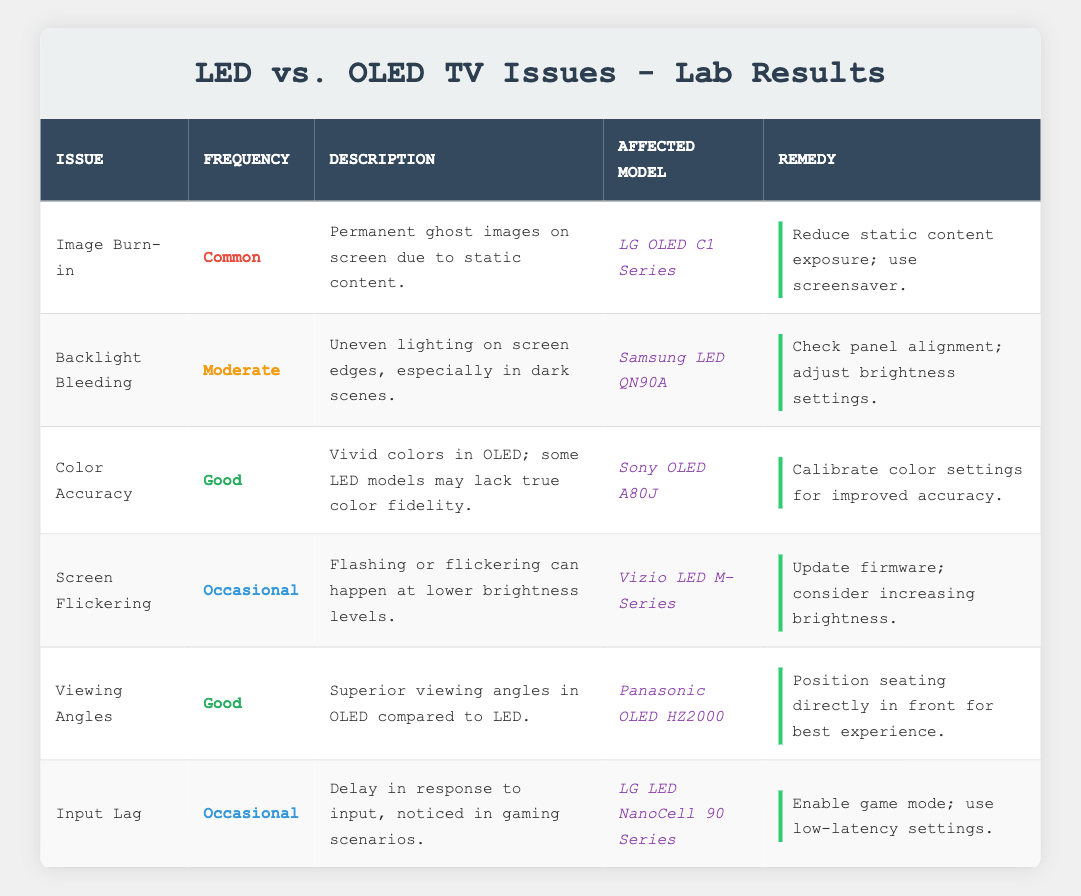What is the most common issue found with OLED televisions? By looking at the "Frequently" column in the table, I can see that "Image Burn-in" is labeled as "Common" for the affected model LG OLED C1 Series.
Answer: Image Burn-in Which model has a moderate issue with backlight bleeding? The table lists "Backlight Bleeding" under the affected model "Samsung LED QN90A" with a frequency of "Moderate."
Answer: Samsung LED QN90A What remedy is suggested for screen flickering in the Vizio LED M-Series? The remedy for screen flickering in the Vizio LED M-Series is to "Update firmware; consider increasing brightness," as shown in the table.
Answer: Update firmware; consider increasing brightness Is color accuracy noted as a problem for OLED models? The table notes that OLED models like the Sony OLED A80J have "Good" color accuracy, indicating that this is not a major problem for such models.
Answer: No Which issue has the frequency categorized as "Occasional"? By checking the frequency column, I identify "Screen Flickering" and "Input Lag" listed as occurring occasionally.
Answer: Screen Flickering, Input Lag Which type of television (LED or OLED) is mentioned to have superior viewing angles? The table states that OLED televisions, specifically the Panasonic OLED HZ2000, have "Superior viewing angles" compared to LED models.
Answer: OLED What is the remedy for the input lag experienced in gaming with the LG LED NanoCell 90 Series? The remedy according to the table is to "Enable game mode; use low-latency settings," which addresses the input lag.
Answer: Enable game mode; use low-latency settings How many issues are noted as being classified with a frequency of "Good"? There are two issues categorized as "Good" in the table: "Color Accuracy" and "Viewing Angles," thus the total is two.
Answer: 2 Is backlight bleeding considered more frequent than input lag? Backlight bleeding is marked as "Moderate" while input lag is classified as "Occasional," thus backlight bleeding is indeed more frequent.
Answer: Yes Which is the affected model for color accuracy issues, and what is the suggested remedy? The affected model for color accuracy is the Sony OLED A80J, and the remedy provided in the table is to "Calibrate color settings for improved accuracy."
Answer: Sony OLED A80J; Calibrate color settings for improved accuracy 